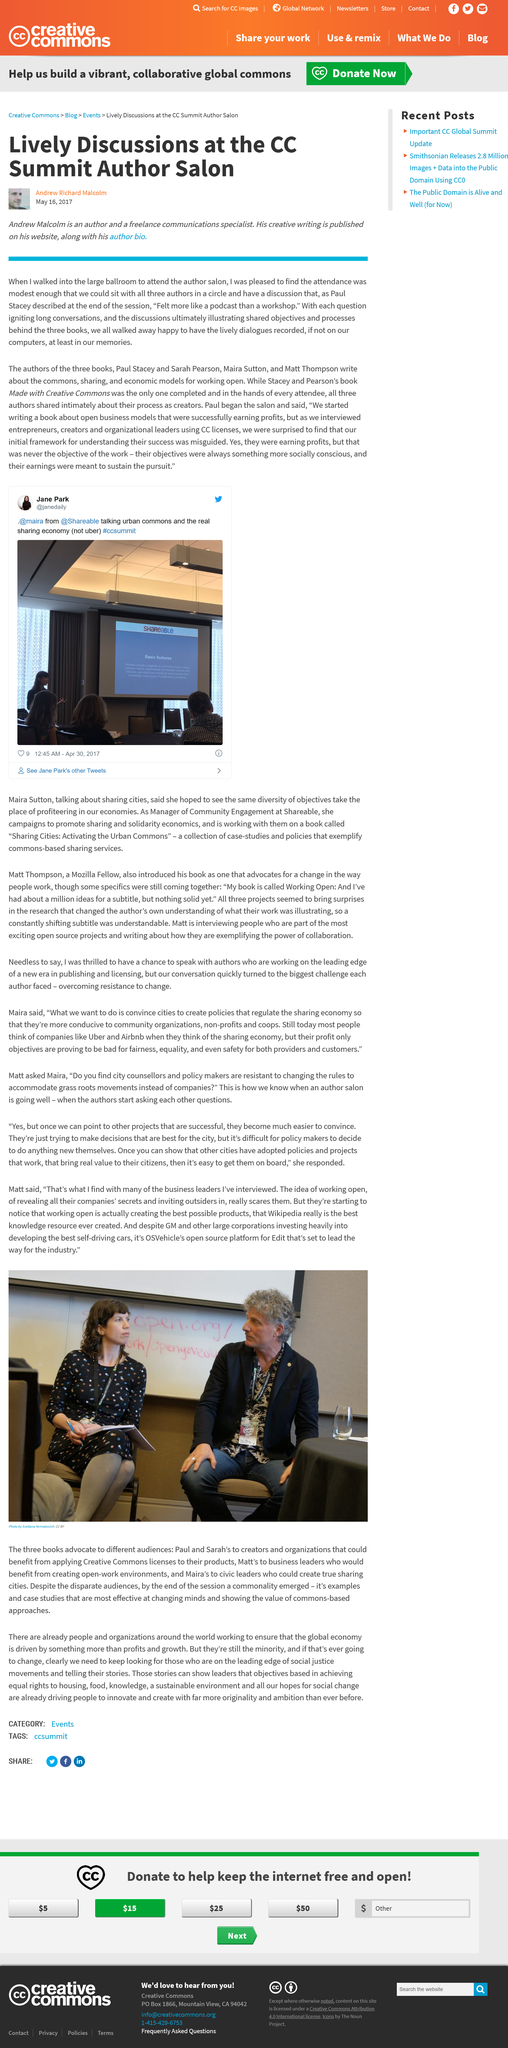Indicate a few pertinent items in this graphic. Andrew Malcolm, in addition to being an author, serves as a freelance communications specialist. The discussions at the CC Summit Author Salon were lively, as reported by Andrew Malcolm. The man in the small portrait below the title is named Andrew Richard Malcolm. 